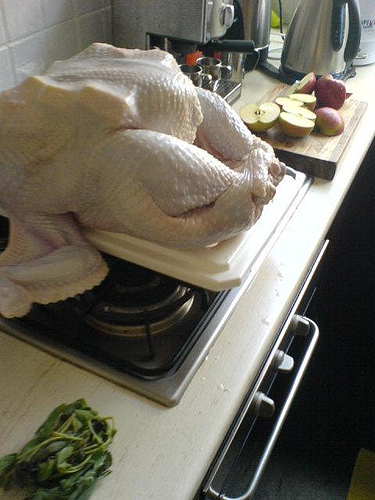<image>
Is the apple on the counter? Yes. Looking at the image, I can see the apple is positioned on top of the counter, with the counter providing support. 